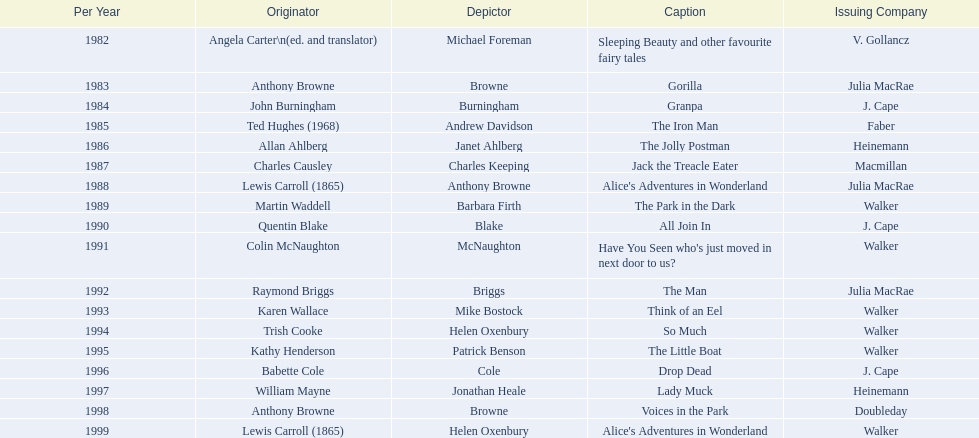Which author wrote the first award winner? Angela Carter. 